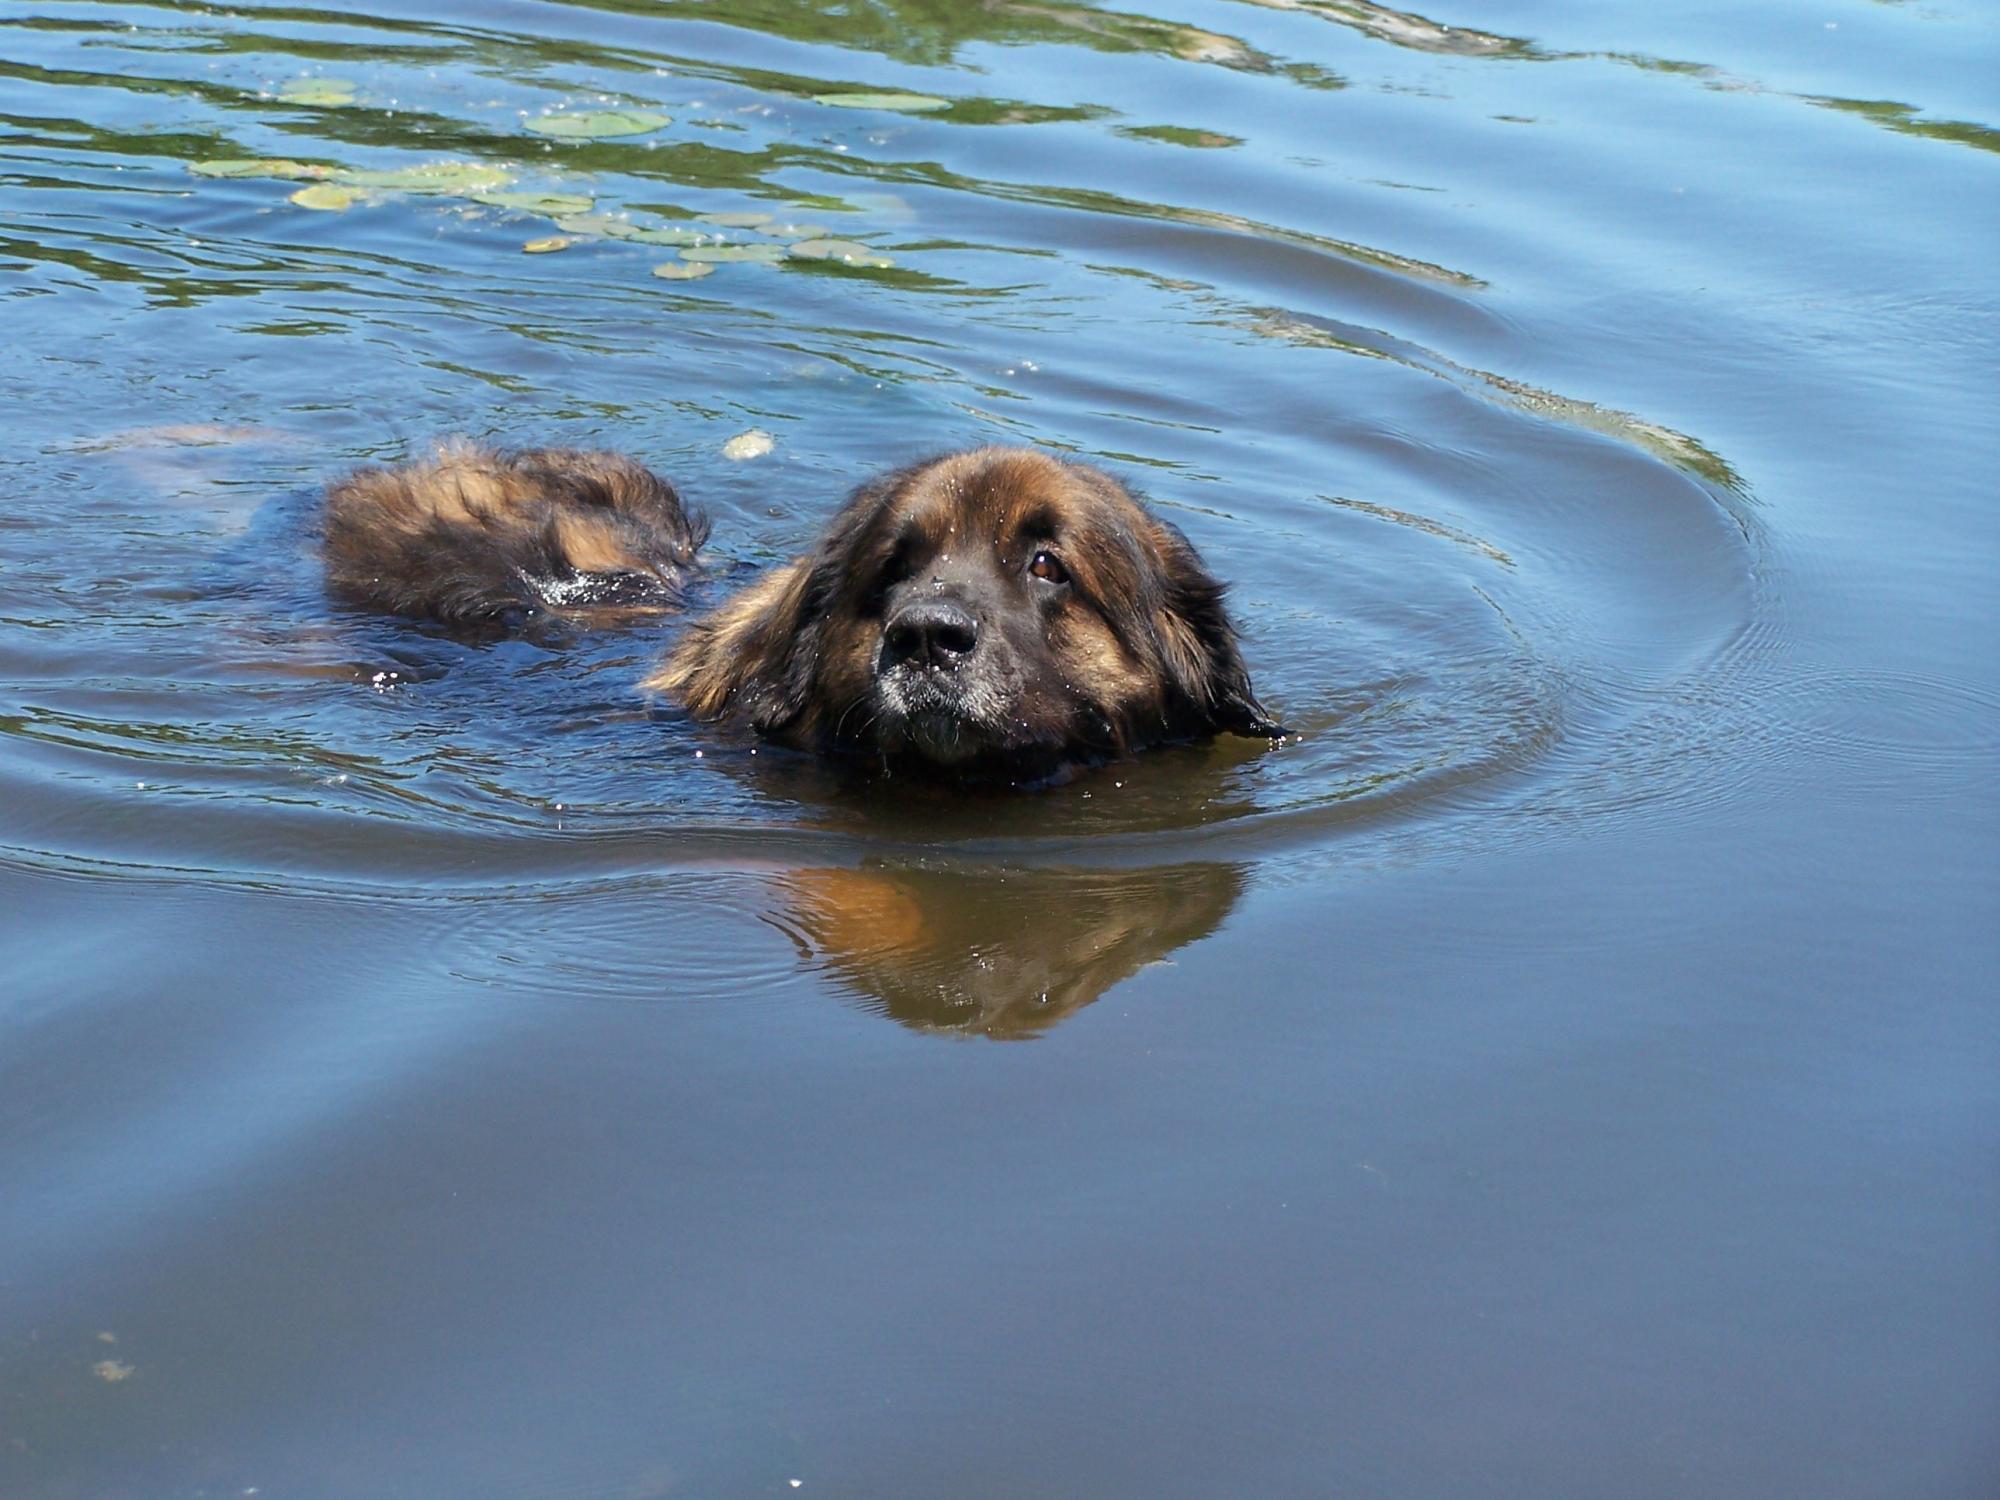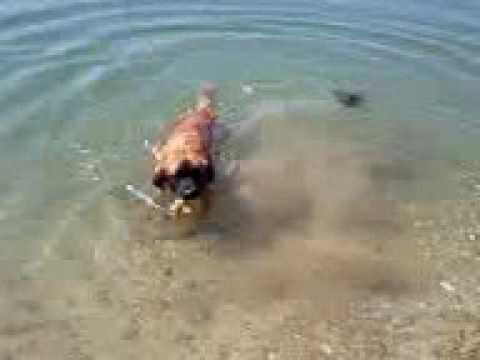The first image is the image on the left, the second image is the image on the right. For the images displayed, is the sentence "The dog in the right image is in water facing towards the left." factually correct? Answer yes or no. No. The first image is the image on the left, the second image is the image on the right. For the images displayed, is the sentence "Two dog are in a natural body of water." factually correct? Answer yes or no. Yes. 